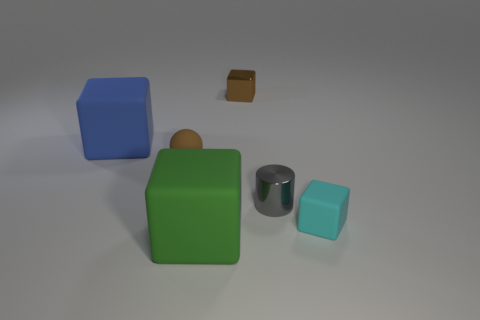Subtract all brown blocks. How many blocks are left? 3 Add 4 cyan matte cylinders. How many objects exist? 10 Subtract all red blocks. Subtract all gray balls. How many blocks are left? 4 Subtract all balls. How many objects are left? 5 Add 4 small brown blocks. How many small brown blocks are left? 5 Add 1 green objects. How many green objects exist? 2 Subtract 1 blue blocks. How many objects are left? 5 Subtract all tiny yellow cylinders. Subtract all blocks. How many objects are left? 2 